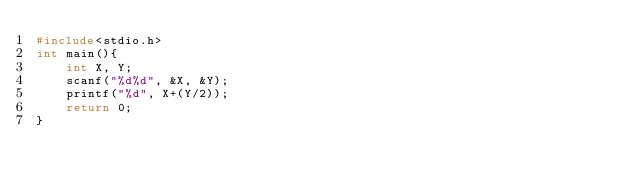<code> <loc_0><loc_0><loc_500><loc_500><_C_>#include<stdio.h>
int main(){
	int X, Y;
	scanf("%d%d", &X, &Y);
	printf("%d", X+(Y/2));
	return 0;
}</code> 